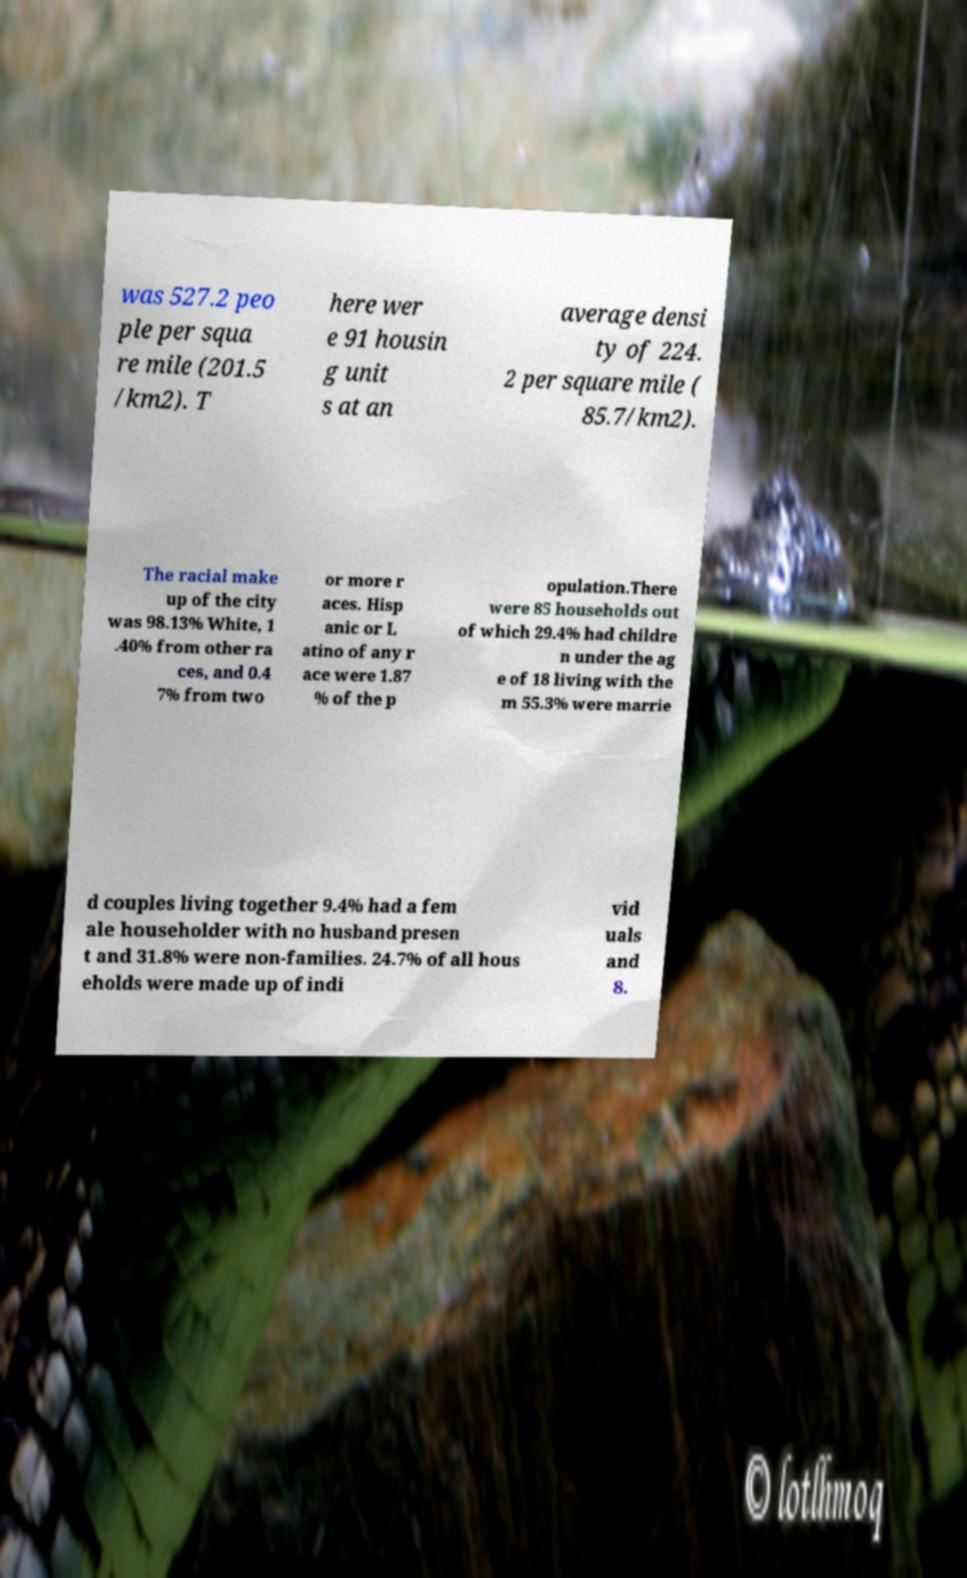Could you assist in decoding the text presented in this image and type it out clearly? was 527.2 peo ple per squa re mile (201.5 /km2). T here wer e 91 housin g unit s at an average densi ty of 224. 2 per square mile ( 85.7/km2). The racial make up of the city was 98.13% White, 1 .40% from other ra ces, and 0.4 7% from two or more r aces. Hisp anic or L atino of any r ace were 1.87 % of the p opulation.There were 85 households out of which 29.4% had childre n under the ag e of 18 living with the m 55.3% were marrie d couples living together 9.4% had a fem ale householder with no husband presen t and 31.8% were non-families. 24.7% of all hous eholds were made up of indi vid uals and 8. 